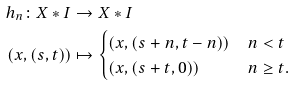Convert formula to latex. <formula><loc_0><loc_0><loc_500><loc_500>h _ { n } \colon X \ast I & \to X \ast I \\ ( x , ( s , t ) ) & \mapsto \begin{cases} ( x , ( s + n , t - n ) ) & n < t \\ ( x , ( s + t , 0 ) ) & n \geq t . \end{cases}</formula> 